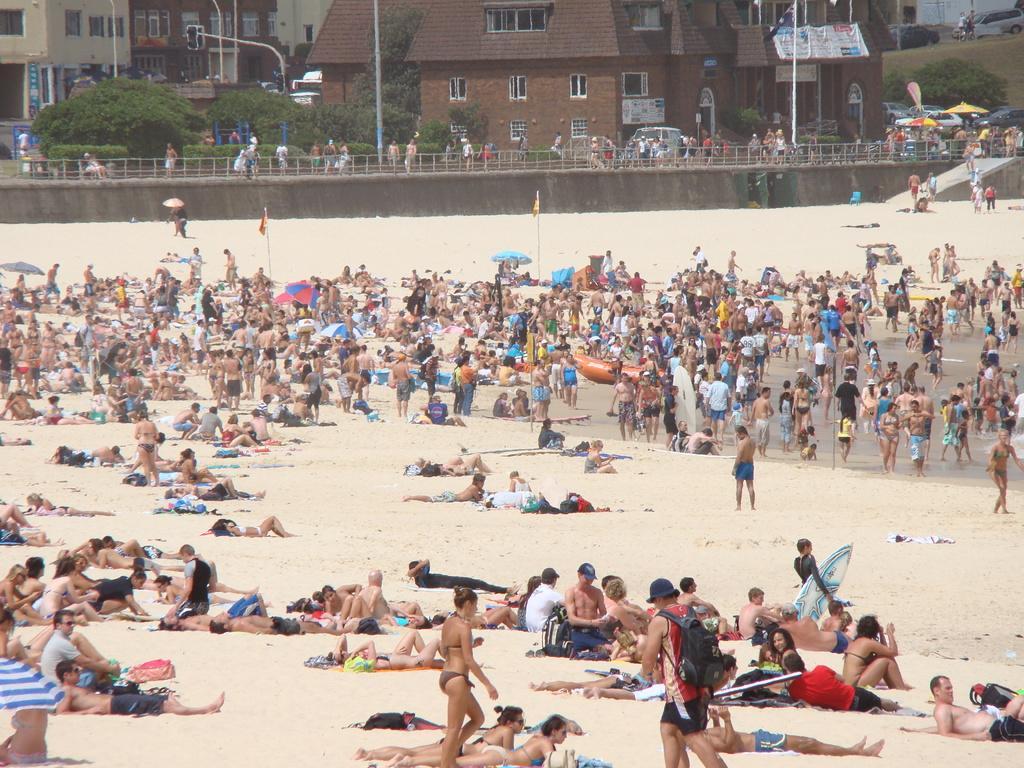Can you describe this image briefly? In the picture, it looks like sand surface in front of the beach. There are a lot of people relaxing on the sand and some of them are standing. Behind them there are buildings and houses and trees. 